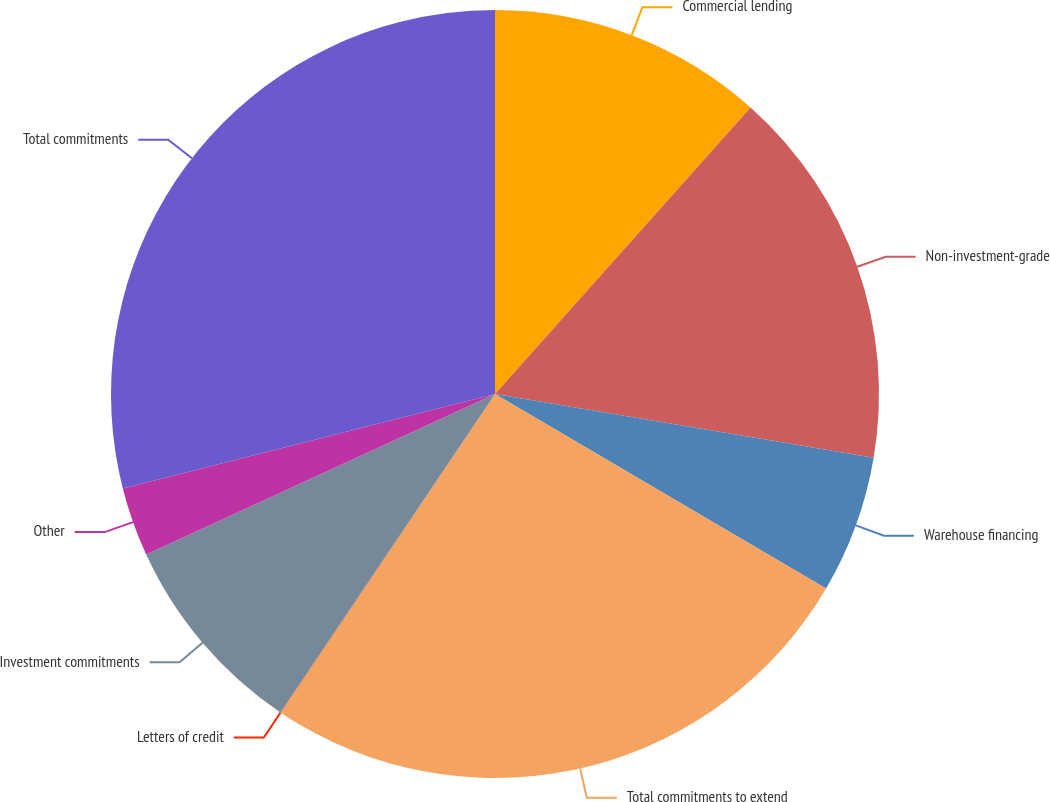Convert chart to OTSL. <chart><loc_0><loc_0><loc_500><loc_500><pie_chart><fcel>Commercial lending<fcel>Non-investment-grade<fcel>Warehouse financing<fcel>Total commitments to extend<fcel>Letters of credit<fcel>Investment commitments<fcel>Other<fcel>Total commitments<nl><fcel>11.59%<fcel>16.07%<fcel>5.8%<fcel>25.97%<fcel>0.01%<fcel>8.7%<fcel>2.91%<fcel>28.96%<nl></chart> 